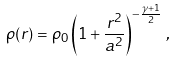<formula> <loc_0><loc_0><loc_500><loc_500>\rho ( r ) = \rho _ { 0 } \left ( 1 + \frac { r ^ { 2 } } { a ^ { 2 } } \right ) ^ { - \frac { \gamma + 1 } { 2 } } \, ,</formula> 